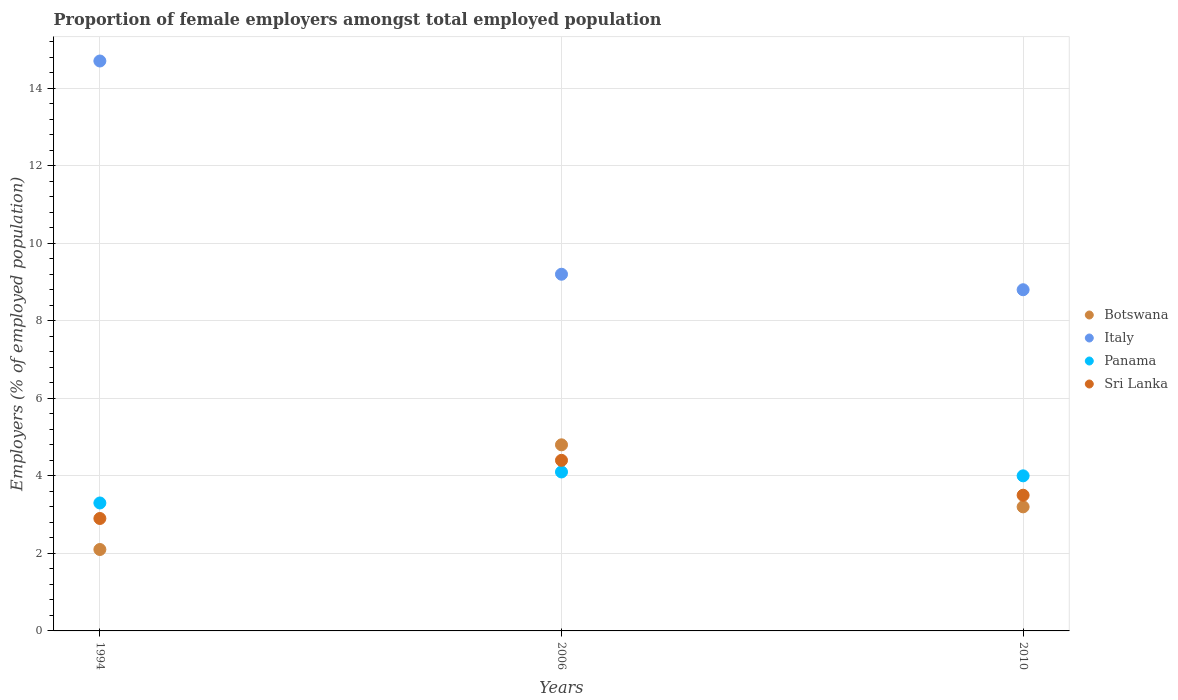How many different coloured dotlines are there?
Make the answer very short. 4. Is the number of dotlines equal to the number of legend labels?
Provide a short and direct response. Yes. What is the proportion of female employers in Sri Lanka in 1994?
Give a very brief answer. 2.9. Across all years, what is the maximum proportion of female employers in Italy?
Offer a very short reply. 14.7. Across all years, what is the minimum proportion of female employers in Sri Lanka?
Ensure brevity in your answer.  2.9. In which year was the proportion of female employers in Botswana minimum?
Ensure brevity in your answer.  1994. What is the total proportion of female employers in Botswana in the graph?
Your response must be concise. 10.1. What is the difference between the proportion of female employers in Sri Lanka in 1994 and that in 2010?
Ensure brevity in your answer.  -0.6. What is the difference between the proportion of female employers in Panama in 1994 and the proportion of female employers in Sri Lanka in 2010?
Your answer should be compact. -0.2. What is the average proportion of female employers in Sri Lanka per year?
Your response must be concise. 3.6. In the year 2010, what is the difference between the proportion of female employers in Panama and proportion of female employers in Botswana?
Provide a short and direct response. 0.8. What is the ratio of the proportion of female employers in Botswana in 1994 to that in 2010?
Make the answer very short. 0.66. What is the difference between the highest and the second highest proportion of female employers in Panama?
Your answer should be very brief. 0.1. What is the difference between the highest and the lowest proportion of female employers in Italy?
Offer a terse response. 5.9. In how many years, is the proportion of female employers in Botswana greater than the average proportion of female employers in Botswana taken over all years?
Your response must be concise. 1. Is it the case that in every year, the sum of the proportion of female employers in Sri Lanka and proportion of female employers in Botswana  is greater than the sum of proportion of female employers in Italy and proportion of female employers in Panama?
Make the answer very short. No. How many dotlines are there?
Offer a very short reply. 4. How many years are there in the graph?
Provide a succinct answer. 3. Are the values on the major ticks of Y-axis written in scientific E-notation?
Provide a short and direct response. No. Does the graph contain any zero values?
Offer a very short reply. No. Does the graph contain grids?
Ensure brevity in your answer.  Yes. Where does the legend appear in the graph?
Ensure brevity in your answer.  Center right. How are the legend labels stacked?
Provide a succinct answer. Vertical. What is the title of the graph?
Your answer should be very brief. Proportion of female employers amongst total employed population. What is the label or title of the X-axis?
Provide a short and direct response. Years. What is the label or title of the Y-axis?
Your answer should be compact. Employers (% of employed population). What is the Employers (% of employed population) in Botswana in 1994?
Offer a very short reply. 2.1. What is the Employers (% of employed population) of Italy in 1994?
Your answer should be very brief. 14.7. What is the Employers (% of employed population) in Panama in 1994?
Give a very brief answer. 3.3. What is the Employers (% of employed population) of Sri Lanka in 1994?
Your answer should be compact. 2.9. What is the Employers (% of employed population) of Botswana in 2006?
Your response must be concise. 4.8. What is the Employers (% of employed population) in Italy in 2006?
Your response must be concise. 9.2. What is the Employers (% of employed population) in Panama in 2006?
Offer a terse response. 4.1. What is the Employers (% of employed population) of Sri Lanka in 2006?
Keep it short and to the point. 4.4. What is the Employers (% of employed population) in Botswana in 2010?
Ensure brevity in your answer.  3.2. What is the Employers (% of employed population) of Italy in 2010?
Offer a very short reply. 8.8. What is the Employers (% of employed population) of Panama in 2010?
Keep it short and to the point. 4. What is the Employers (% of employed population) in Sri Lanka in 2010?
Your answer should be very brief. 3.5. Across all years, what is the maximum Employers (% of employed population) in Botswana?
Your response must be concise. 4.8. Across all years, what is the maximum Employers (% of employed population) of Italy?
Your answer should be very brief. 14.7. Across all years, what is the maximum Employers (% of employed population) of Panama?
Make the answer very short. 4.1. Across all years, what is the maximum Employers (% of employed population) in Sri Lanka?
Provide a short and direct response. 4.4. Across all years, what is the minimum Employers (% of employed population) of Botswana?
Give a very brief answer. 2.1. Across all years, what is the minimum Employers (% of employed population) of Italy?
Provide a short and direct response. 8.8. Across all years, what is the minimum Employers (% of employed population) in Panama?
Provide a short and direct response. 3.3. Across all years, what is the minimum Employers (% of employed population) of Sri Lanka?
Your answer should be very brief. 2.9. What is the total Employers (% of employed population) in Italy in the graph?
Your response must be concise. 32.7. What is the difference between the Employers (% of employed population) of Italy in 1994 and that in 2006?
Make the answer very short. 5.5. What is the difference between the Employers (% of employed population) in Panama in 1994 and that in 2010?
Offer a terse response. -0.7. What is the difference between the Employers (% of employed population) in Botswana in 2006 and that in 2010?
Provide a succinct answer. 1.6. What is the difference between the Employers (% of employed population) in Sri Lanka in 2006 and that in 2010?
Make the answer very short. 0.9. What is the difference between the Employers (% of employed population) in Botswana in 1994 and the Employers (% of employed population) in Sri Lanka in 2006?
Your answer should be compact. -2.3. What is the difference between the Employers (% of employed population) of Italy in 1994 and the Employers (% of employed population) of Sri Lanka in 2006?
Offer a very short reply. 10.3. What is the difference between the Employers (% of employed population) in Botswana in 1994 and the Employers (% of employed population) in Italy in 2010?
Your answer should be very brief. -6.7. What is the difference between the Employers (% of employed population) in Botswana in 1994 and the Employers (% of employed population) in Sri Lanka in 2010?
Offer a terse response. -1.4. What is the difference between the Employers (% of employed population) of Italy in 1994 and the Employers (% of employed population) of Panama in 2010?
Give a very brief answer. 10.7. What is the difference between the Employers (% of employed population) of Panama in 1994 and the Employers (% of employed population) of Sri Lanka in 2010?
Give a very brief answer. -0.2. What is the difference between the Employers (% of employed population) in Botswana in 2006 and the Employers (% of employed population) in Italy in 2010?
Offer a terse response. -4. What is the difference between the Employers (% of employed population) of Botswana in 2006 and the Employers (% of employed population) of Sri Lanka in 2010?
Give a very brief answer. 1.3. What is the difference between the Employers (% of employed population) of Italy in 2006 and the Employers (% of employed population) of Panama in 2010?
Offer a terse response. 5.2. What is the difference between the Employers (% of employed population) in Panama in 2006 and the Employers (% of employed population) in Sri Lanka in 2010?
Provide a short and direct response. 0.6. What is the average Employers (% of employed population) in Botswana per year?
Ensure brevity in your answer.  3.37. What is the average Employers (% of employed population) of Panama per year?
Make the answer very short. 3.8. What is the average Employers (% of employed population) of Sri Lanka per year?
Your response must be concise. 3.6. In the year 1994, what is the difference between the Employers (% of employed population) in Botswana and Employers (% of employed population) in Panama?
Your answer should be compact. -1.2. In the year 1994, what is the difference between the Employers (% of employed population) of Italy and Employers (% of employed population) of Panama?
Ensure brevity in your answer.  11.4. In the year 1994, what is the difference between the Employers (% of employed population) of Italy and Employers (% of employed population) of Sri Lanka?
Offer a terse response. 11.8. In the year 1994, what is the difference between the Employers (% of employed population) in Panama and Employers (% of employed population) in Sri Lanka?
Give a very brief answer. 0.4. In the year 2006, what is the difference between the Employers (% of employed population) in Italy and Employers (% of employed population) in Sri Lanka?
Provide a short and direct response. 4.8. In the year 2006, what is the difference between the Employers (% of employed population) of Panama and Employers (% of employed population) of Sri Lanka?
Your answer should be compact. -0.3. In the year 2010, what is the difference between the Employers (% of employed population) of Botswana and Employers (% of employed population) of Panama?
Provide a succinct answer. -0.8. In the year 2010, what is the difference between the Employers (% of employed population) in Italy and Employers (% of employed population) in Panama?
Ensure brevity in your answer.  4.8. In the year 2010, what is the difference between the Employers (% of employed population) of Panama and Employers (% of employed population) of Sri Lanka?
Provide a short and direct response. 0.5. What is the ratio of the Employers (% of employed population) in Botswana in 1994 to that in 2006?
Your answer should be very brief. 0.44. What is the ratio of the Employers (% of employed population) in Italy in 1994 to that in 2006?
Provide a succinct answer. 1.6. What is the ratio of the Employers (% of employed population) in Panama in 1994 to that in 2006?
Offer a very short reply. 0.8. What is the ratio of the Employers (% of employed population) in Sri Lanka in 1994 to that in 2006?
Your response must be concise. 0.66. What is the ratio of the Employers (% of employed population) of Botswana in 1994 to that in 2010?
Make the answer very short. 0.66. What is the ratio of the Employers (% of employed population) of Italy in 1994 to that in 2010?
Make the answer very short. 1.67. What is the ratio of the Employers (% of employed population) of Panama in 1994 to that in 2010?
Make the answer very short. 0.82. What is the ratio of the Employers (% of employed population) of Sri Lanka in 1994 to that in 2010?
Provide a short and direct response. 0.83. What is the ratio of the Employers (% of employed population) of Botswana in 2006 to that in 2010?
Ensure brevity in your answer.  1.5. What is the ratio of the Employers (% of employed population) in Italy in 2006 to that in 2010?
Provide a short and direct response. 1.05. What is the ratio of the Employers (% of employed population) in Sri Lanka in 2006 to that in 2010?
Your response must be concise. 1.26. What is the difference between the highest and the second highest Employers (% of employed population) in Botswana?
Provide a succinct answer. 1.6. What is the difference between the highest and the second highest Employers (% of employed population) of Panama?
Offer a very short reply. 0.1. What is the difference between the highest and the second highest Employers (% of employed population) of Sri Lanka?
Give a very brief answer. 0.9. What is the difference between the highest and the lowest Employers (% of employed population) of Italy?
Your response must be concise. 5.9. What is the difference between the highest and the lowest Employers (% of employed population) in Panama?
Offer a terse response. 0.8. 